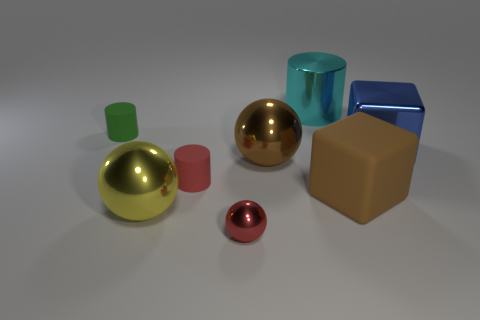Does the rubber thing that is left of the yellow shiny object have the same color as the large rubber cube?
Your answer should be compact. No. How many balls are green things or large metallic objects?
Keep it short and to the point. 2. There is a object that is behind the tiny object behind the red cylinder in front of the large brown sphere; how big is it?
Provide a short and direct response. Large. There is a brown shiny object that is the same size as the cyan metal cylinder; what shape is it?
Your response must be concise. Sphere. There is a large blue shiny object; what shape is it?
Offer a very short reply. Cube. Is the tiny red thing that is in front of the brown rubber object made of the same material as the green thing?
Your answer should be compact. No. What is the size of the cylinder that is to the left of the small matte thing in front of the large blue metallic block?
Provide a succinct answer. Small. There is a cylinder that is behind the metallic cube and in front of the cyan cylinder; what color is it?
Your response must be concise. Green. What is the material of the yellow sphere that is the same size as the blue thing?
Ensure brevity in your answer.  Metal. What number of other things are there of the same material as the large brown ball
Keep it short and to the point. 4. 